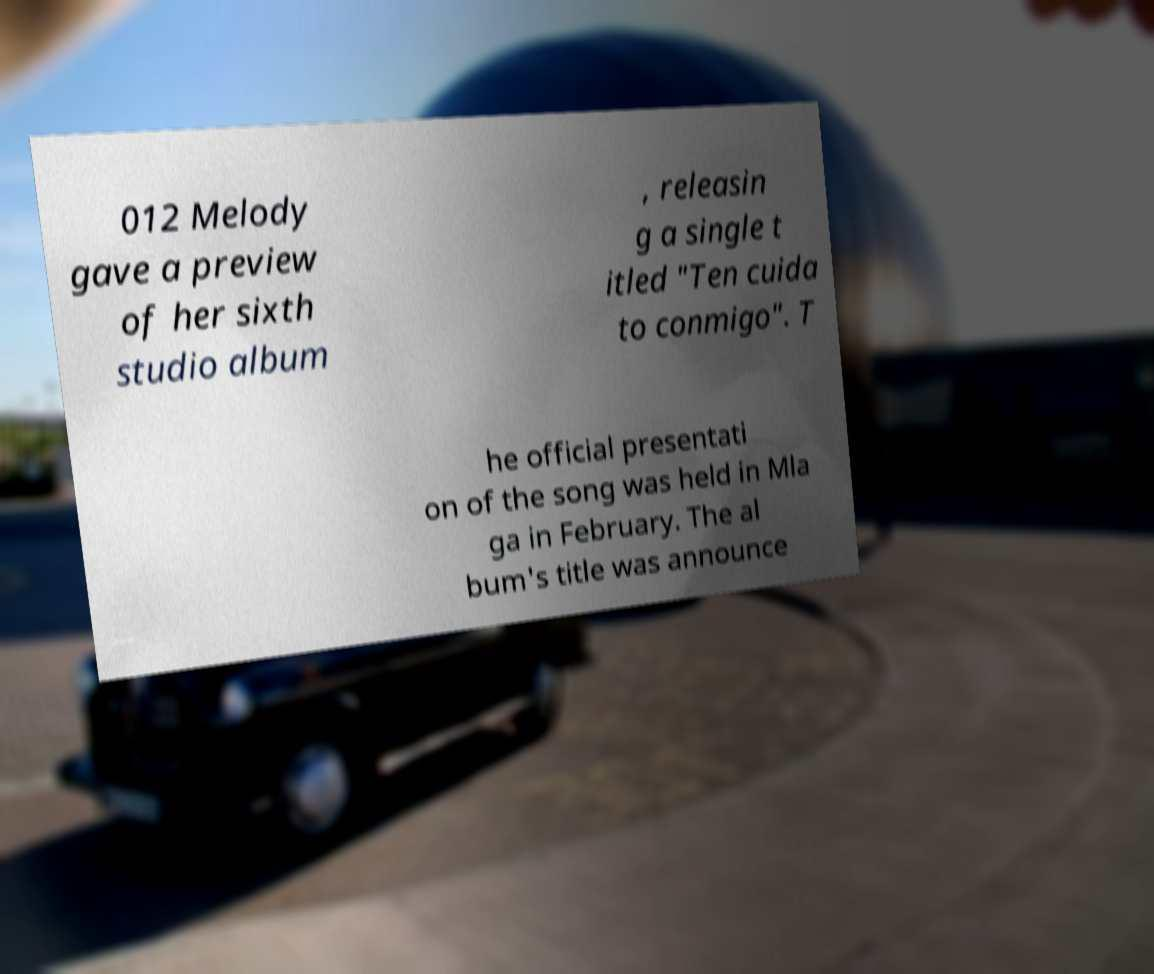There's text embedded in this image that I need extracted. Can you transcribe it verbatim? 012 Melody gave a preview of her sixth studio album , releasin g a single t itled "Ten cuida to conmigo". T he official presentati on of the song was held in Mla ga in February. The al bum's title was announce 